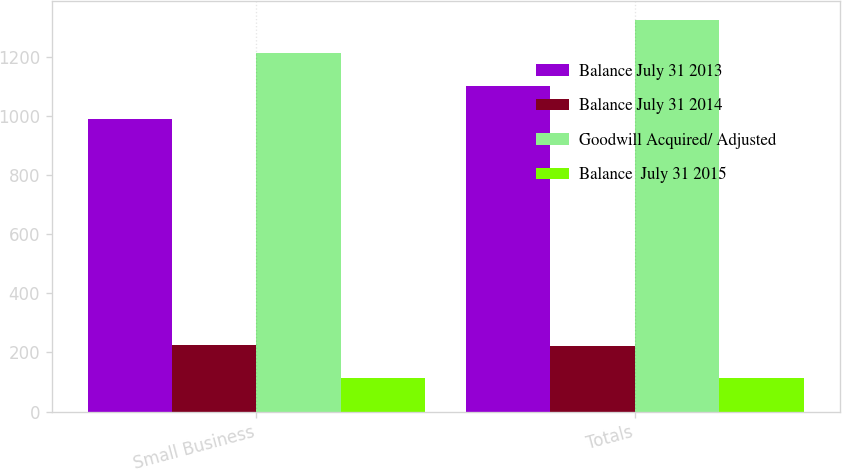<chart> <loc_0><loc_0><loc_500><loc_500><stacked_bar_chart><ecel><fcel>Small Business<fcel>Totals<nl><fcel>Balance July 31 2013<fcel>988<fcel>1100<nl><fcel>Balance July 31 2014<fcel>225<fcel>223<nl><fcel>Goodwill Acquired/ Adjusted<fcel>1213<fcel>1323<nl><fcel>Balance  July 31 2015<fcel>114<fcel>114<nl></chart> 